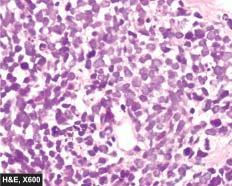what are the tumour cells arranged in?
Answer the question using a single word or phrase. Sheets 